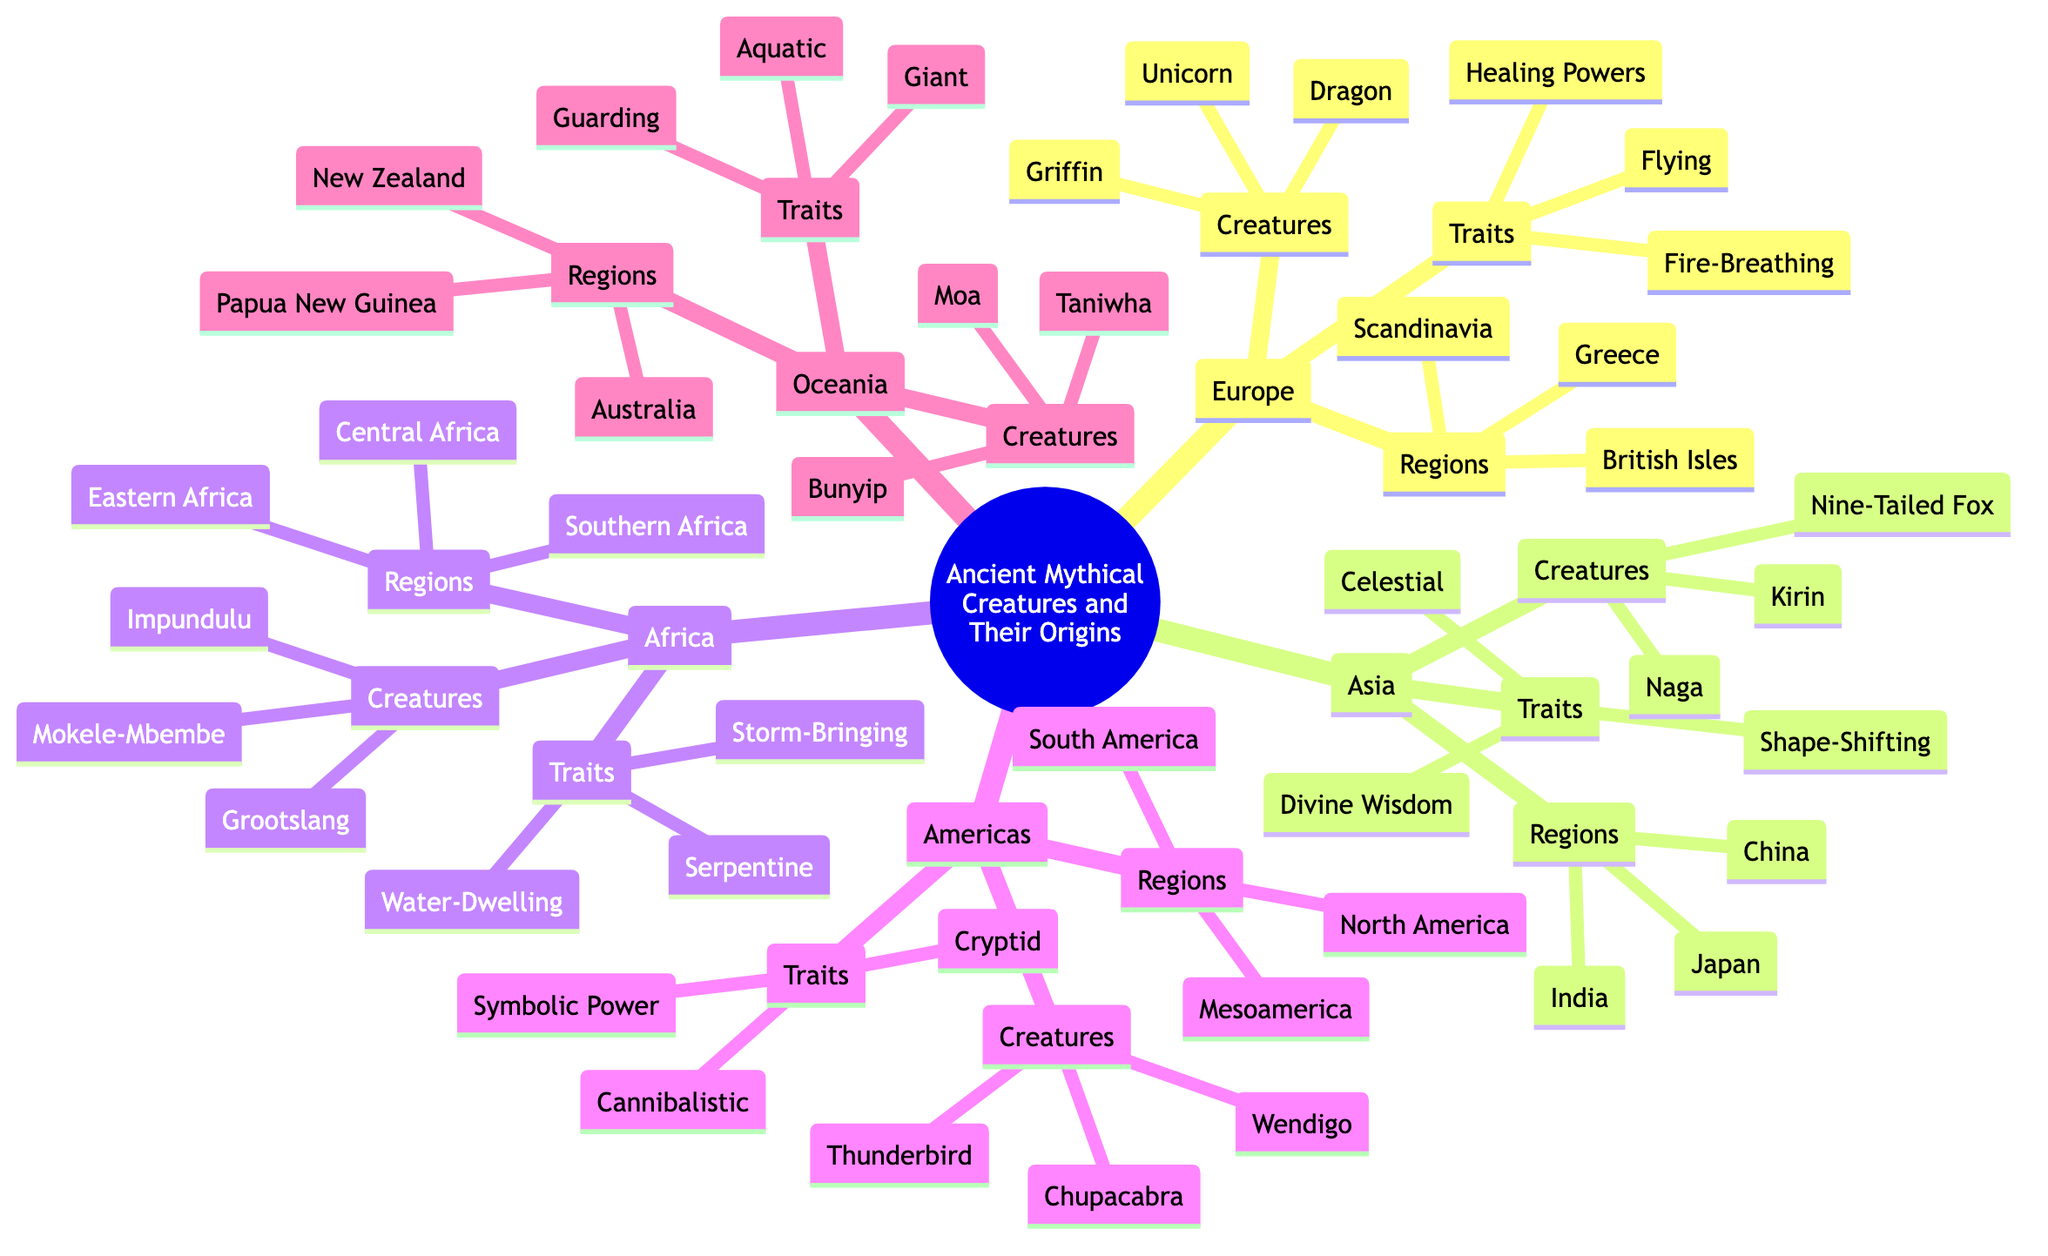What are the three mythical creatures listed under Europe? The question asks for a specific set of information from the "Creatures" sub-branch under the "Europe" main branch. By locating the "Europe" branch, I can see its "Creatures" sub-branch contains three elements: Dragon, Griffin, and Unicorn.
Answer: Dragon, Griffin, Unicorn Which region is associated with the Naga? This question requires us to find the region that corresponds to the creature "Naga." Upon examining the "Asia" branch, I can see that "Naga" is listed under the "Creatures" sub-branch, and "Asia" is also associated with the region "India." Thus, "Naga" is associated with the region of India.
Answer: India How many traits are listed under Africa? To answer this, I check the "Africa" main branch and its "Traits" sub-branch. Counting the elements in that branch, I see that there are three traits listed: Water-Dwelling, Serpentine, and Storm-Bringing. Therefore, the total number is three.
Answer: 3 Which region from the Americas branch has a creature called Thunderbird? The question requires me to identify the specific region associated with the creature "Thunderbird" from the Americas branch. In the "Creatures" sub-branch under "Americas," I see "Thunderbird" listed, and I cross-reference it with the "Regions" sub-branch to determine it belongs to North America.
Answer: North America What traits do the creatures from Oceania share? This question is asking for the common traits listed under the "Traits" sub-branch in the "Oceania" branch. I examine the Oceania branch and find three shared traits: Aquatic, Guarding, and Giant.
Answer: Aquatic, Guarding, Giant Which mythological creature is associated with divine wisdom in Asia? To answer this, I investigate the "Asia" branch and look through the "Creatures" sub-branch to see the creature associated with "Divine Wisdom," a specific trait also listed in that branch. The "Kirin" is the creature linked to this quality.
Answer: Kirin How many regions are mentioned in Africa? The question asks for the number of regions specifically under the African branch. Upon reviewing the "Regions" sub-branch under "Africa," I count three regions: Central Africa, Southern Africa, and Eastern Africa, resulting in a total of three.
Answer: 3 What is a common characteristic of mythical creatures in Europe? This question seeks to identify a common trait from the "Traits" sub-branch of the "Europe" main branch. I inspect the "Traits" sub-branch and see that "Fire-Breathing" is one of the qualities attributed to European mythical creatures, indicating a common trait associated with them.
Answer: Fire-Breathing 